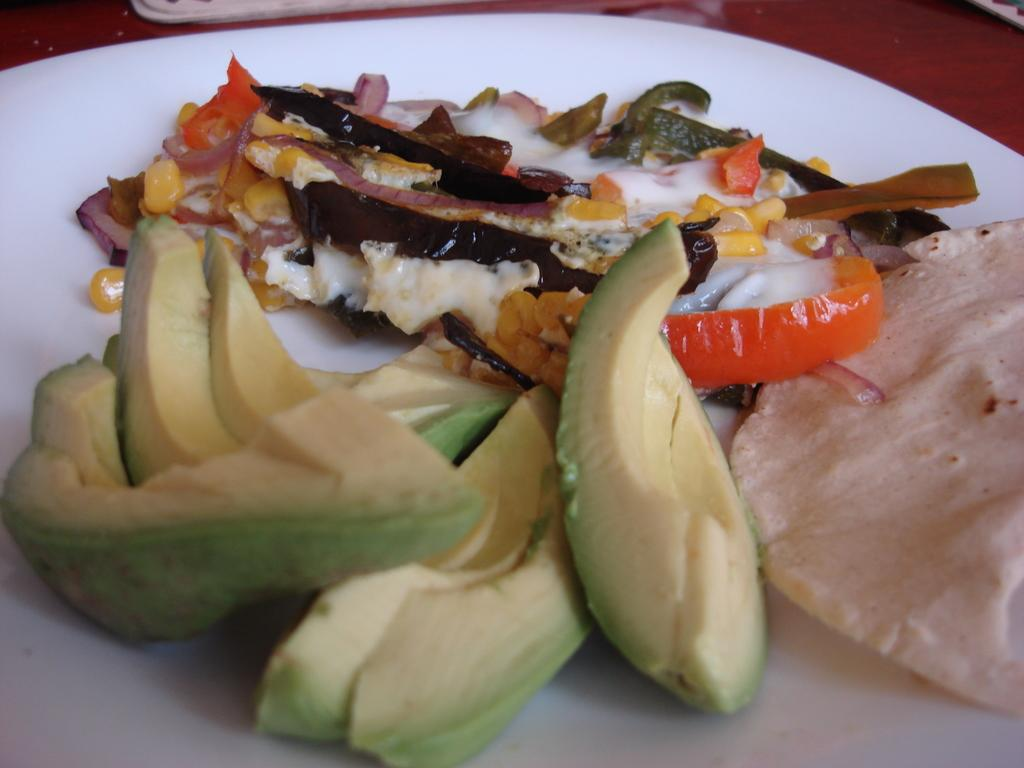What type of food can be seen in the image? There are avocado pieces in the image. What else is on the plate with the avocado pieces? There are other food items on a white plate in the image. What letter is written on the avocado pieces in the image? There are no letters written on the avocado pieces in the image. What reason might someone have for placing a stone on the plate with the avocado pieces? There is no stone present on the plate with the avocado pieces in the image. 